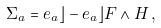<formula> <loc_0><loc_0><loc_500><loc_500>\Sigma _ { a } = e _ { a } \rfloor \L - e _ { a } \rfloor F \wedge H \, ,</formula> 